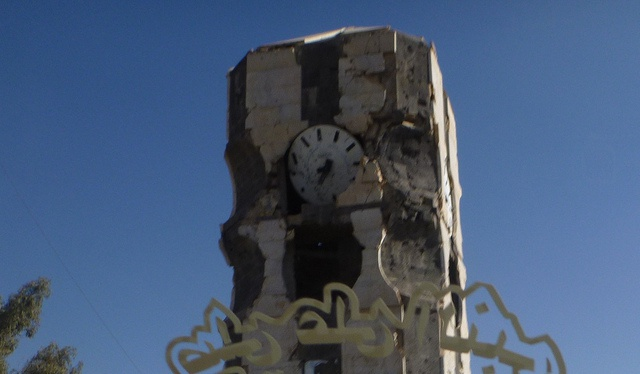Describe the objects in this image and their specific colors. I can see a clock in darkblue, black, and gray tones in this image. 